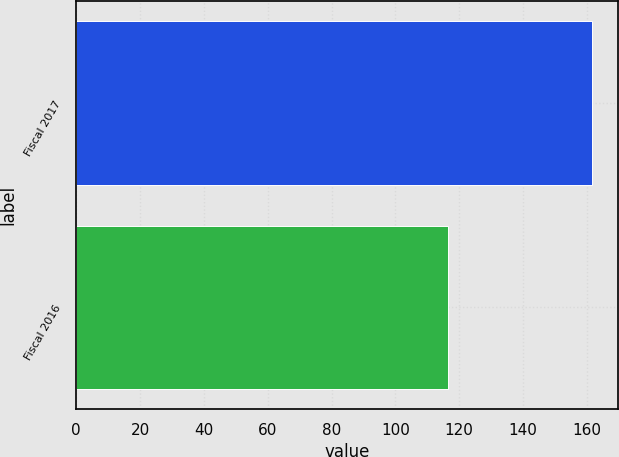Convert chart to OTSL. <chart><loc_0><loc_0><loc_500><loc_500><bar_chart><fcel>Fiscal 2017<fcel>Fiscal 2016<nl><fcel>161.8<fcel>116.5<nl></chart> 